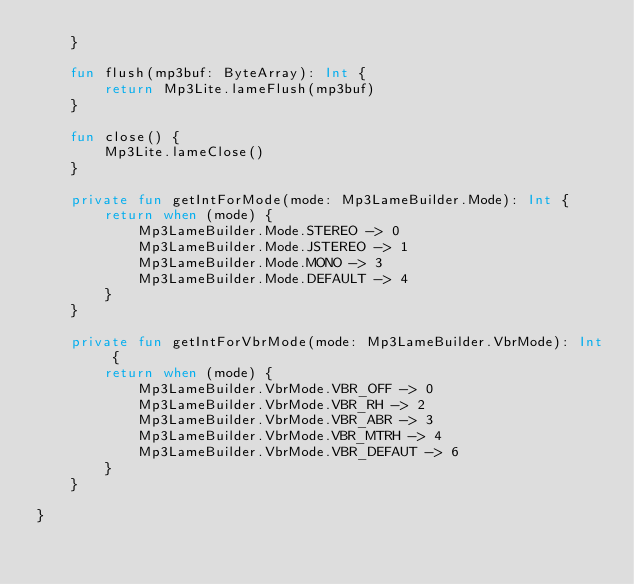Convert code to text. <code><loc_0><loc_0><loc_500><loc_500><_Kotlin_>    }

    fun flush(mp3buf: ByteArray): Int {
        return Mp3Lite.lameFlush(mp3buf)
    }

    fun close() {
        Mp3Lite.lameClose()
    }

    private fun getIntForMode(mode: Mp3LameBuilder.Mode): Int {
        return when (mode) {
            Mp3LameBuilder.Mode.STEREO -> 0
            Mp3LameBuilder.Mode.JSTEREO -> 1
            Mp3LameBuilder.Mode.MONO -> 3
            Mp3LameBuilder.Mode.DEFAULT -> 4
        }
    }

    private fun getIntForVbrMode(mode: Mp3LameBuilder.VbrMode): Int {
        return when (mode) {
            Mp3LameBuilder.VbrMode.VBR_OFF -> 0
            Mp3LameBuilder.VbrMode.VBR_RH -> 2
            Mp3LameBuilder.VbrMode.VBR_ABR -> 3
            Mp3LameBuilder.VbrMode.VBR_MTRH -> 4
            Mp3LameBuilder.VbrMode.VBR_DEFAUT -> 6
        }
    }

}
</code> 